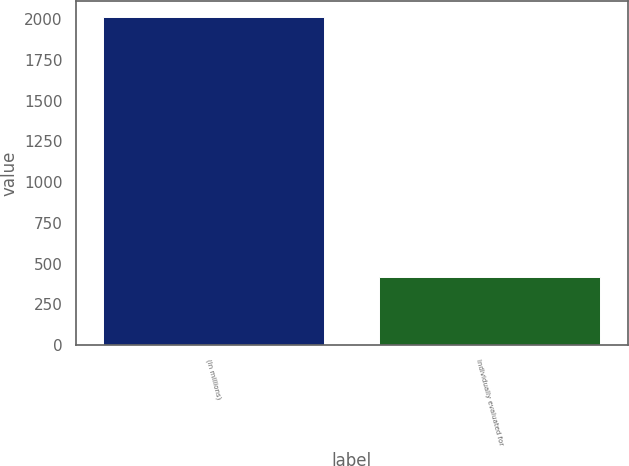Convert chart. <chart><loc_0><loc_0><loc_500><loc_500><bar_chart><fcel>(In millions)<fcel>Individually evaluated for<nl><fcel>2011<fcel>421<nl></chart> 